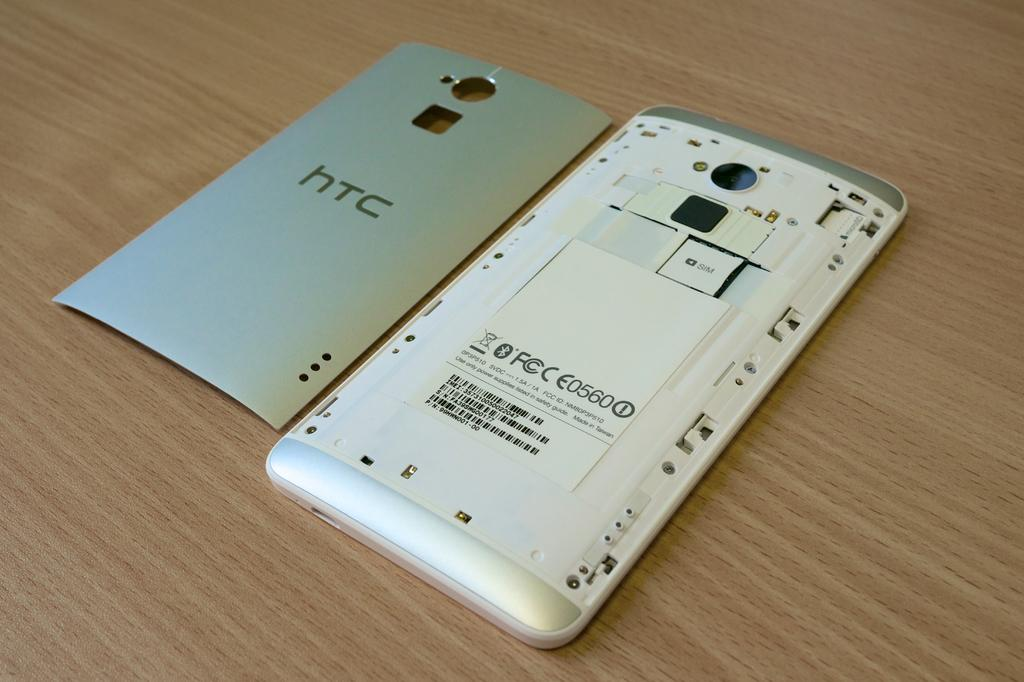<image>
Summarize the visual content of the image. The back of a phone case showing a battery, the case says HTC 